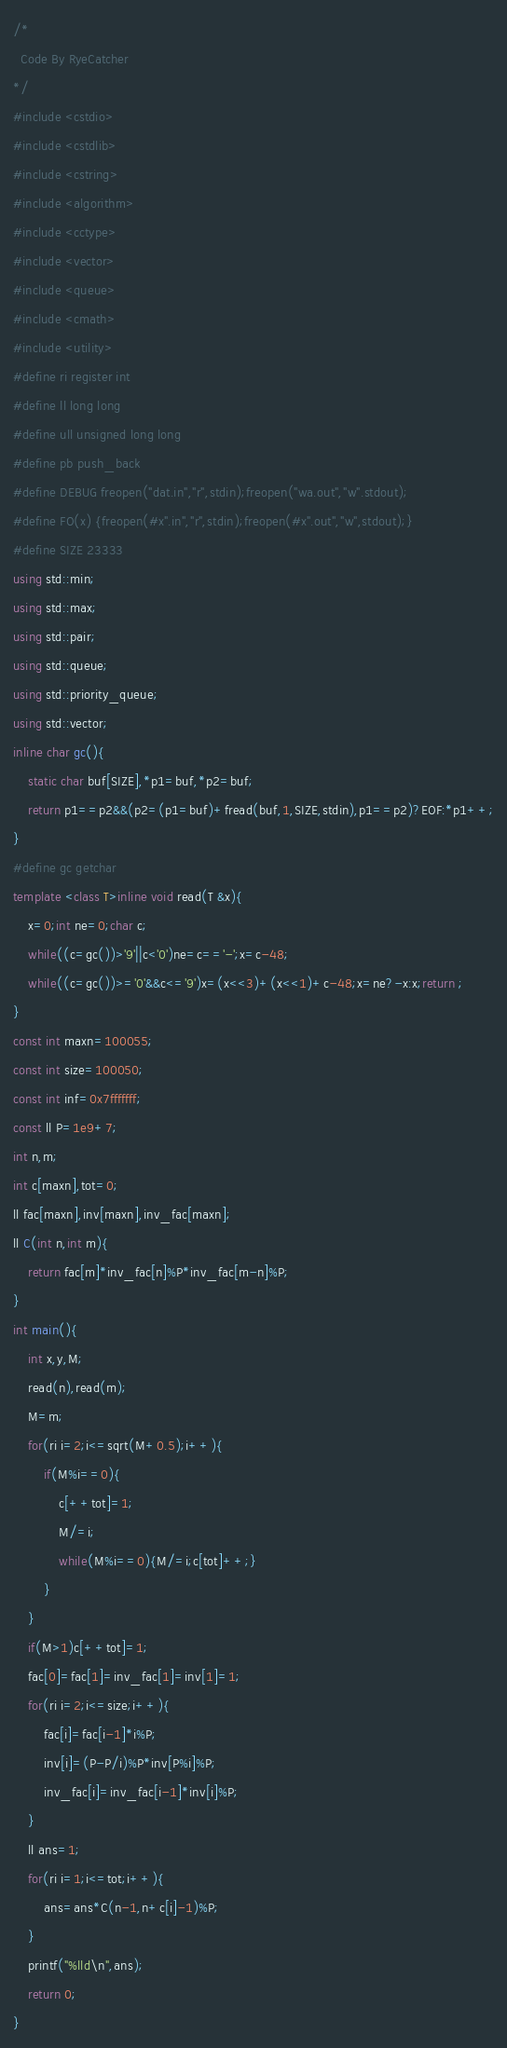Convert code to text. <code><loc_0><loc_0><loc_500><loc_500><_C++_>/*
  Code By RyeCatcher
*/
#include <cstdio>
#include <cstdlib>
#include <cstring>
#include <algorithm>
#include <cctype>
#include <vector>
#include <queue>
#include <cmath>
#include <utility>
#define ri register int
#define ll long long
#define ull unsigned long long
#define pb push_back
#define DEBUG freopen("dat.in","r",stdin);freopen("wa.out","w".stdout);
#define FO(x) {freopen(#x".in","r",stdin);freopen(#x".out","w",stdout);}
#define SIZE 23333
using std::min;
using std::max;
using std::pair;
using std::queue;
using std::priority_queue;
using std::vector;
inline char gc(){
    static char buf[SIZE],*p1=buf,*p2=buf;
    return p1==p2&&(p2=(p1=buf)+fread(buf,1,SIZE,stdin),p1==p2)?EOF:*p1++;
}
#define gc getchar
template <class T>inline void read(T &x){
	x=0;int ne=0;char c;
    while((c=gc())>'9'||c<'0')ne=c=='-';x=c-48;
    while((c=gc())>='0'&&c<='9')x=(x<<3)+(x<<1)+c-48;x=ne?-x:x;return ;
}
const int maxn=100055;
const int size=100050;
const int inf=0x7fffffff;
const ll P=1e9+7;
int n,m;
int c[maxn],tot=0;
ll fac[maxn],inv[maxn],inv_fac[maxn];
ll C(int n,int m){
	return fac[m]*inv_fac[n]%P*inv_fac[m-n]%P;
}
int main(){
	int x,y,M;
	read(n),read(m);
	M=m;
	for(ri i=2;i<=sqrt(M+0.5);i++){
		if(M%i==0){
			c[++tot]=1;
			M/=i;
			while(M%i==0){M/=i;c[tot]++;}
		}
	}
	if(M>1)c[++tot]=1;
	fac[0]=fac[1]=inv_fac[1]=inv[1]=1;
	for(ri i=2;i<=size;i++){
		fac[i]=fac[i-1]*i%P;
		inv[i]=(P-P/i)%P*inv[P%i]%P;
		inv_fac[i]=inv_fac[i-1]*inv[i]%P;
	}
	ll ans=1;
	for(ri i=1;i<=tot;i++){
		ans=ans*C(n-1,n+c[i]-1)%P;
	}
	printf("%lld\n",ans);
	return 0;
}</code> 